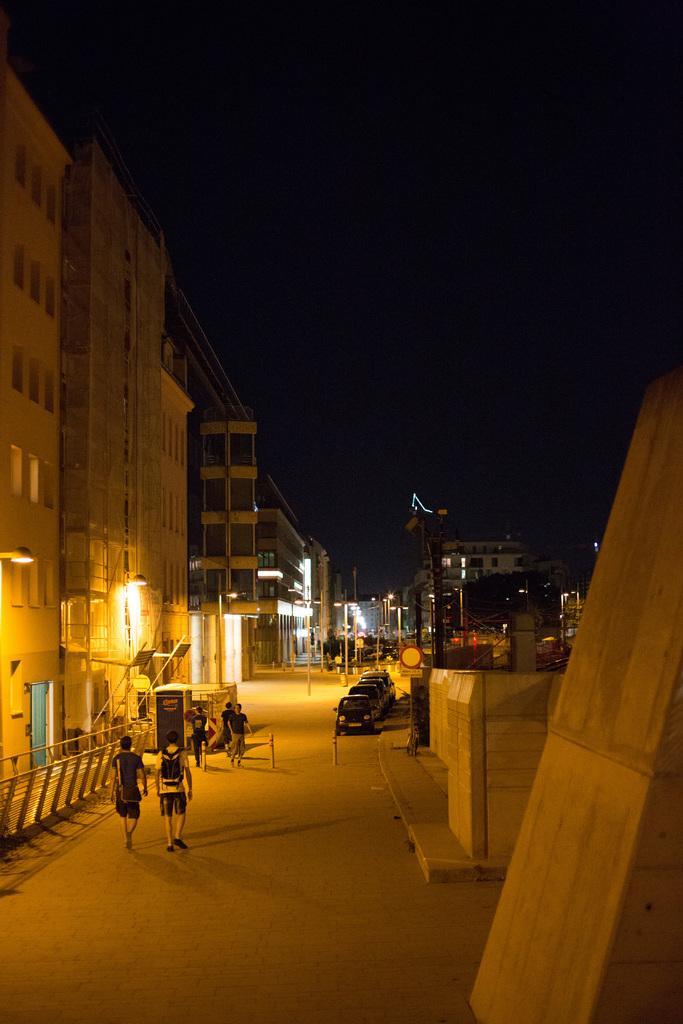Could you give a brief overview of what you see in this image? In this image we can see buildings with windows, people, vehicles, light poles and we can also see the sky. 